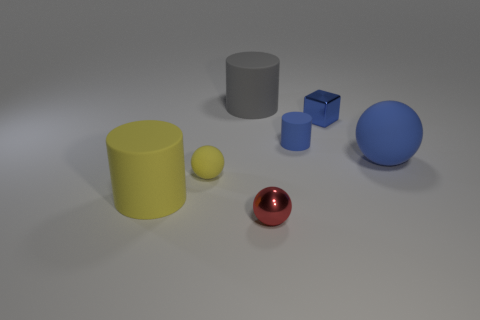There is a matte sphere that is the same color as the small cylinder; what is its size?
Provide a succinct answer. Large. How many blocks are large blue rubber things or tiny blue objects?
Keep it short and to the point. 1. Do the yellow object behind the big yellow object and the tiny red shiny thing have the same shape?
Your response must be concise. Yes. Is the number of objects that are on the right side of the large rubber ball greater than the number of gray spheres?
Your answer should be compact. No. What is the color of the cylinder that is the same size as the red thing?
Your response must be concise. Blue. What number of objects are shiny things that are in front of the metal cube or large red metal objects?
Keep it short and to the point. 1. There is a large rubber object that is the same color as the tiny cylinder; what shape is it?
Ensure brevity in your answer.  Sphere. There is a cylinder to the left of the cylinder that is behind the tiny cylinder; what is it made of?
Offer a very short reply. Rubber. Is there a brown ball made of the same material as the large blue ball?
Your response must be concise. No. Are there any tiny metallic balls that are in front of the ball that is in front of the large yellow rubber object?
Your answer should be very brief. No. 